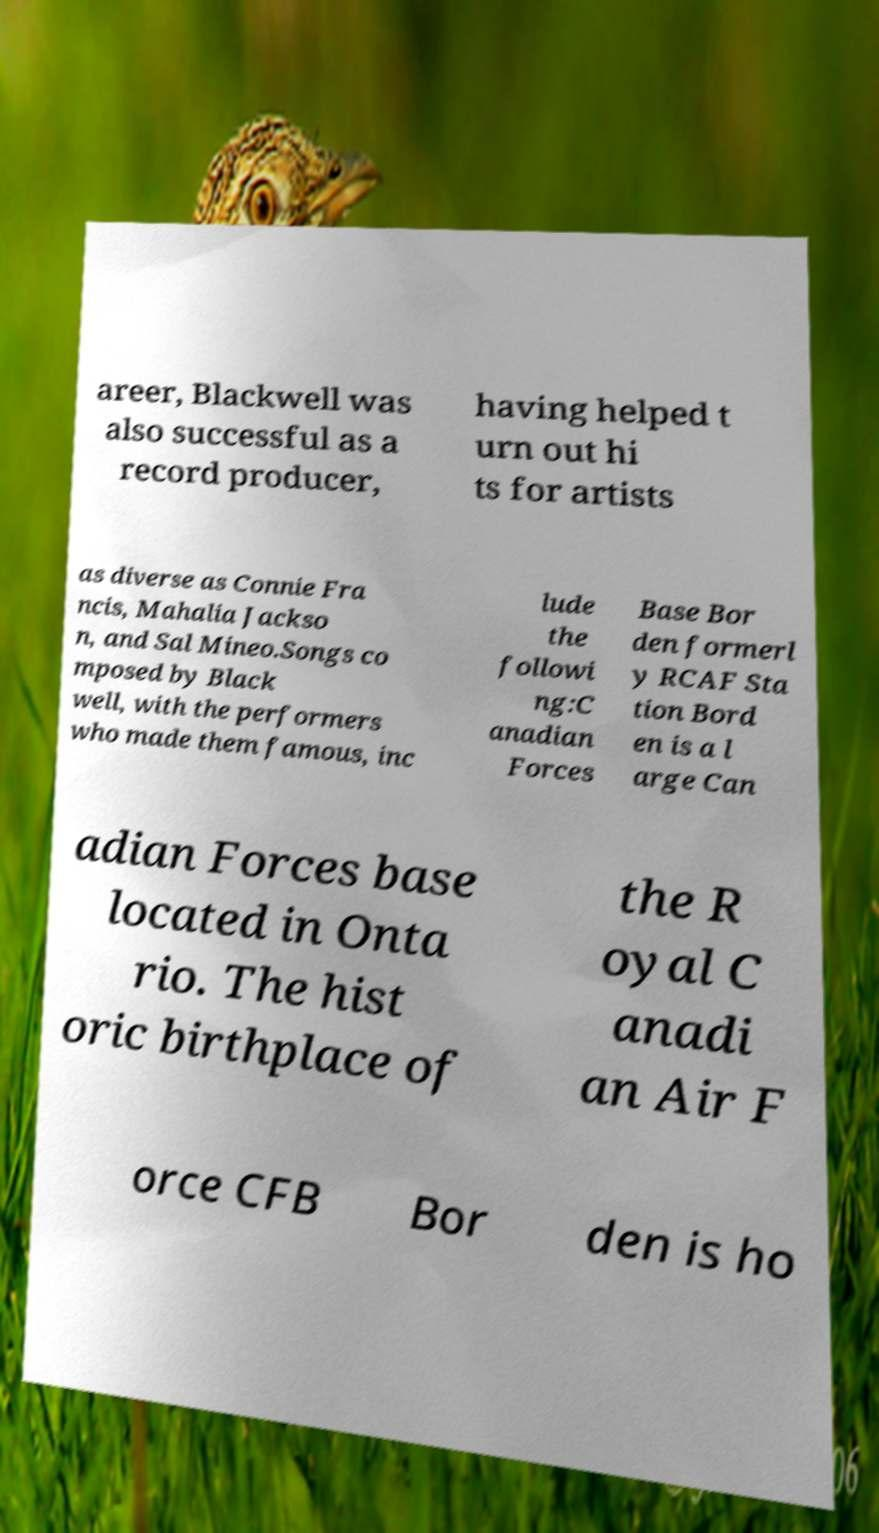Please identify and transcribe the text found in this image. areer, Blackwell was also successful as a record producer, having helped t urn out hi ts for artists as diverse as Connie Fra ncis, Mahalia Jackso n, and Sal Mineo.Songs co mposed by Black well, with the performers who made them famous, inc lude the followi ng:C anadian Forces Base Bor den formerl y RCAF Sta tion Bord en is a l arge Can adian Forces base located in Onta rio. The hist oric birthplace of the R oyal C anadi an Air F orce CFB Bor den is ho 